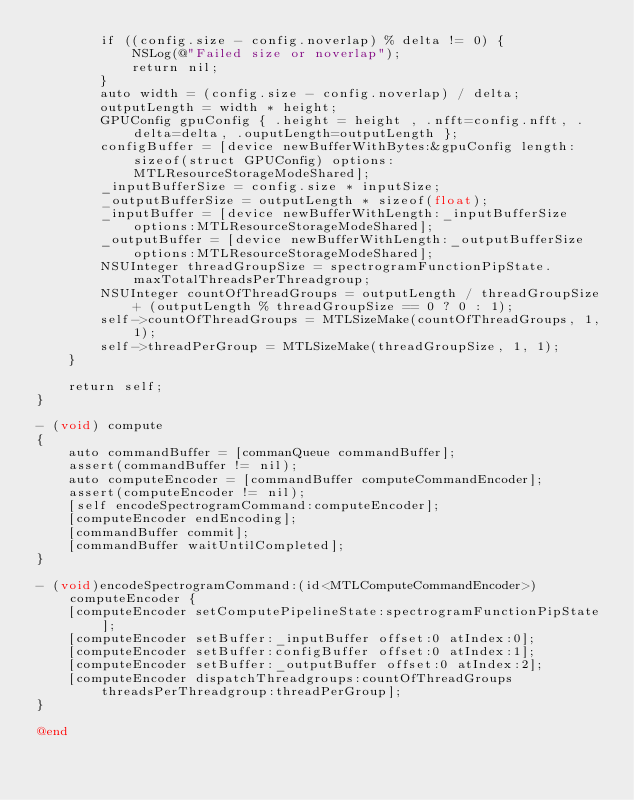<code> <loc_0><loc_0><loc_500><loc_500><_ObjectiveC_>        if ((config.size - config.noverlap) % delta != 0) {
            NSLog(@"Failed size or noverlap");
            return nil;
        }
        auto width = (config.size - config.noverlap) / delta;
        outputLength = width * height;
        GPUConfig gpuConfig { .height = height , .nfft=config.nfft, .delta=delta, .ouputLength=outputLength };
        configBuffer = [device newBufferWithBytes:&gpuConfig length:sizeof(struct GPUConfig) options:MTLResourceStorageModeShared];
        _inputBufferSize = config.size * inputSize;
        _outputBufferSize = outputLength * sizeof(float);
        _inputBuffer = [device newBufferWithLength:_inputBufferSize options:MTLResourceStorageModeShared];
        _outputBuffer = [device newBufferWithLength:_outputBufferSize options:MTLResourceStorageModeShared];
        NSUInteger threadGroupSize = spectrogramFunctionPipState.maxTotalThreadsPerThreadgroup;
        NSUInteger countOfThreadGroups = outputLength / threadGroupSize + (outputLength % threadGroupSize == 0 ? 0 : 1);
        self->countOfThreadGroups = MTLSizeMake(countOfThreadGroups, 1, 1);
        self->threadPerGroup = MTLSizeMake(threadGroupSize, 1, 1);
    }

    return self;
}

- (void) compute
{
    auto commandBuffer = [commanQueue commandBuffer];
    assert(commandBuffer != nil);
    auto computeEncoder = [commandBuffer computeCommandEncoder];
    assert(computeEncoder != nil);
    [self encodeSpectrogramCommand:computeEncoder];
    [computeEncoder endEncoding];
    [commandBuffer commit];
    [commandBuffer waitUntilCompleted];
}

- (void)encodeSpectrogramCommand:(id<MTLComputeCommandEncoder>)computeEncoder {
    [computeEncoder setComputePipelineState:spectrogramFunctionPipState];
    [computeEncoder setBuffer:_inputBuffer offset:0 atIndex:0];
    [computeEncoder setBuffer:configBuffer offset:0 atIndex:1];
    [computeEncoder setBuffer:_outputBuffer offset:0 atIndex:2];
    [computeEncoder dispatchThreadgroups:countOfThreadGroups threadsPerThreadgroup:threadPerGroup];
}

@end
</code> 